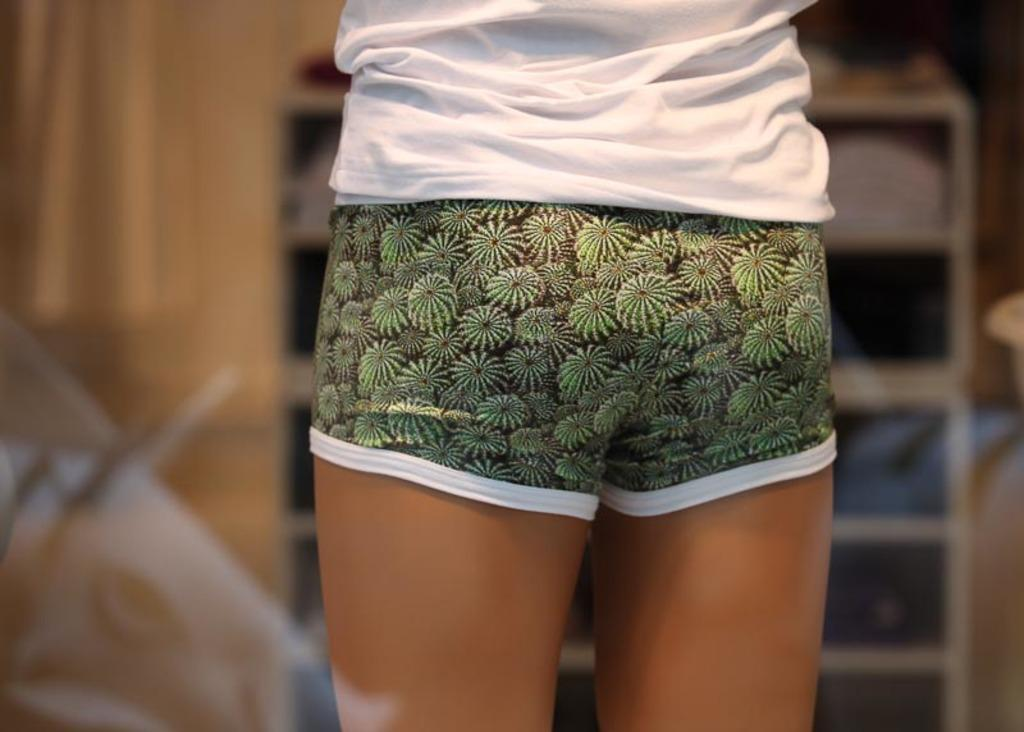What part of a person can be seen in the image? There are legs of a person in the image. What type of clothing is the person wearing on their lower body? The person is wearing shorts. What type of clothing is the person wearing on their upper body? The person is wearing a white t-shirt. Can you describe the background of the image? The background of the image is blurred. What type of mark can be seen on the person's leg in the image? There is no mark visible on the person's leg in the image. What color is the ink used for the text on the person's t-shirt in the image? There is no text or ink visible on the person's t-shirt in the image. 